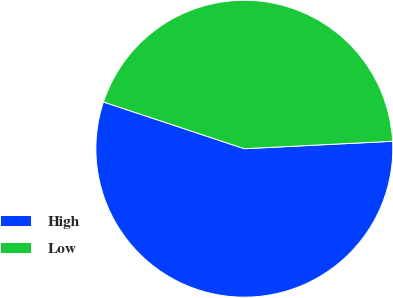Convert chart. <chart><loc_0><loc_0><loc_500><loc_500><pie_chart><fcel>High<fcel>Low<nl><fcel>55.9%<fcel>44.1%<nl></chart> 